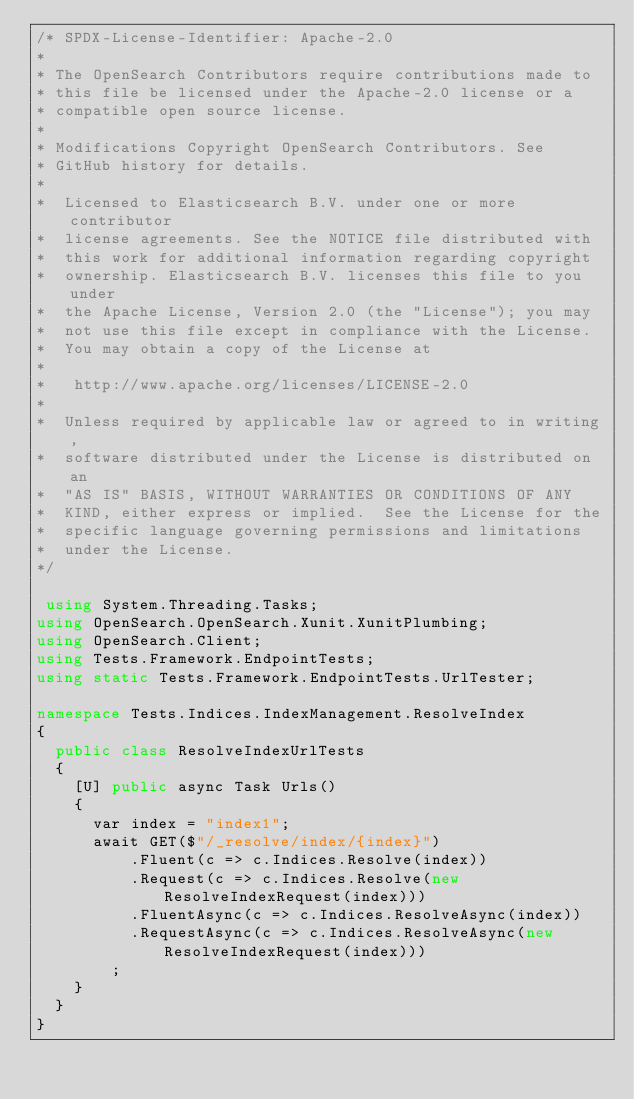Convert code to text. <code><loc_0><loc_0><loc_500><loc_500><_C#_>/* SPDX-License-Identifier: Apache-2.0
*
* The OpenSearch Contributors require contributions made to
* this file be licensed under the Apache-2.0 license or a
* compatible open source license.
*
* Modifications Copyright OpenSearch Contributors. See
* GitHub history for details.
*
*  Licensed to Elasticsearch B.V. under one or more contributor
*  license agreements. See the NOTICE file distributed with
*  this work for additional information regarding copyright
*  ownership. Elasticsearch B.V. licenses this file to you under
*  the Apache License, Version 2.0 (the "License"); you may
*  not use this file except in compliance with the License.
*  You may obtain a copy of the License at
*
* 	http://www.apache.org/licenses/LICENSE-2.0
*
*  Unless required by applicable law or agreed to in writing,
*  software distributed under the License is distributed on an
*  "AS IS" BASIS, WITHOUT WARRANTIES OR CONDITIONS OF ANY
*  KIND, either express or implied.  See the License for the
*  specific language governing permissions and limitations
*  under the License.
*/

 using System.Threading.Tasks;
using OpenSearch.OpenSearch.Xunit.XunitPlumbing;
using OpenSearch.Client;
using Tests.Framework.EndpointTests;
using static Tests.Framework.EndpointTests.UrlTester;

namespace Tests.Indices.IndexManagement.ResolveIndex
{
	public class ResolveIndexUrlTests
	{
		[U] public async Task Urls()
		{
			var index = "index1";
			await GET($"/_resolve/index/{index}")
					.Fluent(c => c.Indices.Resolve(index))
					.Request(c => c.Indices.Resolve(new ResolveIndexRequest(index)))
					.FluentAsync(c => c.Indices.ResolveAsync(index))
					.RequestAsync(c => c.Indices.ResolveAsync(new ResolveIndexRequest(index)))
				;
		}
	}
}
</code> 